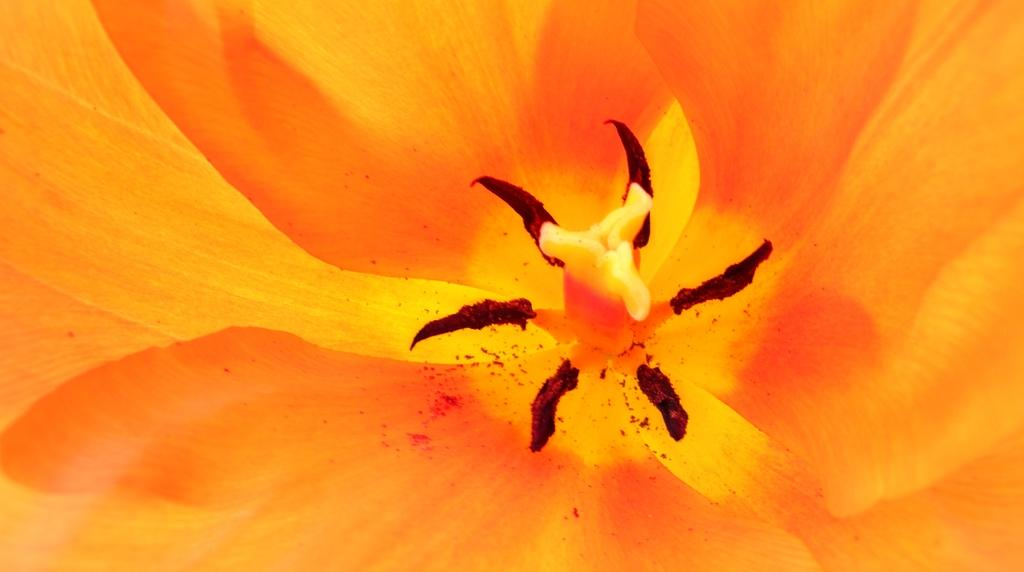What is the main subject of the image? There is a flower in the image. What type of trousers is the flower wearing in the image? The flower is not wearing trousers, as it is a plant and not a person. 